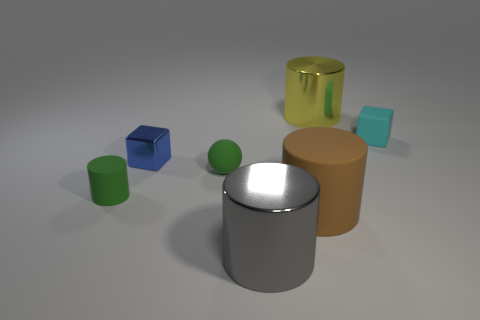How many yellow things are small shiny spheres or large objects? There is one yellow item in the image, which is a large, shiny cylinder. The small shiny sphere is green, not yellow, and there are no yellow small spheres. 